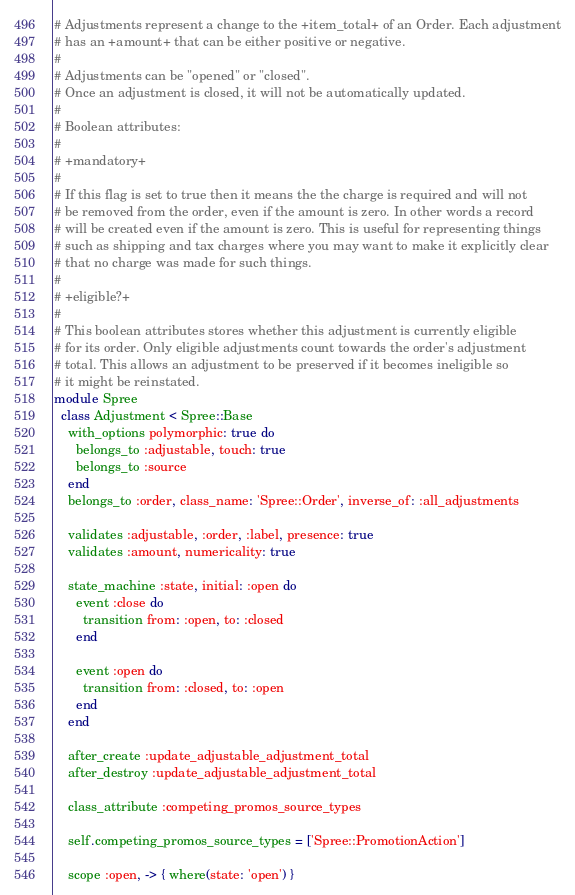Convert code to text. <code><loc_0><loc_0><loc_500><loc_500><_Ruby_># Adjustments represent a change to the +item_total+ of an Order. Each adjustment
# has an +amount+ that can be either positive or negative.
#
# Adjustments can be "opened" or "closed".
# Once an adjustment is closed, it will not be automatically updated.
#
# Boolean attributes:
#
# +mandatory+
#
# If this flag is set to true then it means the the charge is required and will not
# be removed from the order, even if the amount is zero. In other words a record
# will be created even if the amount is zero. This is useful for representing things
# such as shipping and tax charges where you may want to make it explicitly clear
# that no charge was made for such things.
#
# +eligible?+
#
# This boolean attributes stores whether this adjustment is currently eligible
# for its order. Only eligible adjustments count towards the order's adjustment
# total. This allows an adjustment to be preserved if it becomes ineligible so
# it might be reinstated.
module Spree
  class Adjustment < Spree::Base
    with_options polymorphic: true do
      belongs_to :adjustable, touch: true
      belongs_to :source
    end
    belongs_to :order, class_name: 'Spree::Order', inverse_of: :all_adjustments

    validates :adjustable, :order, :label, presence: true
    validates :amount, numericality: true

    state_machine :state, initial: :open do
      event :close do
        transition from: :open, to: :closed
      end

      event :open do
        transition from: :closed, to: :open
      end
    end

    after_create :update_adjustable_adjustment_total
    after_destroy :update_adjustable_adjustment_total

    class_attribute :competing_promos_source_types

    self.competing_promos_source_types = ['Spree::PromotionAction']

    scope :open, -> { where(state: 'open') }</code> 